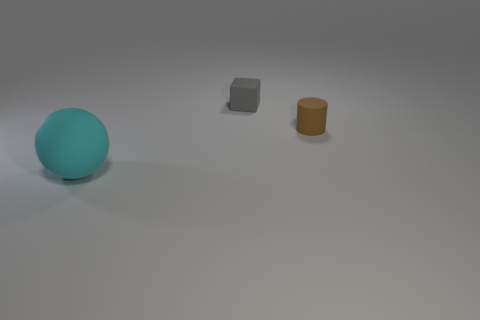Add 1 tiny cylinders. How many objects exist? 4 Subtract all balls. How many objects are left? 2 Add 2 small brown cylinders. How many small brown cylinders are left? 3 Add 2 cyan matte balls. How many cyan matte balls exist? 3 Subtract 1 brown cylinders. How many objects are left? 2 Subtract all big yellow metallic cylinders. Subtract all tiny brown rubber things. How many objects are left? 2 